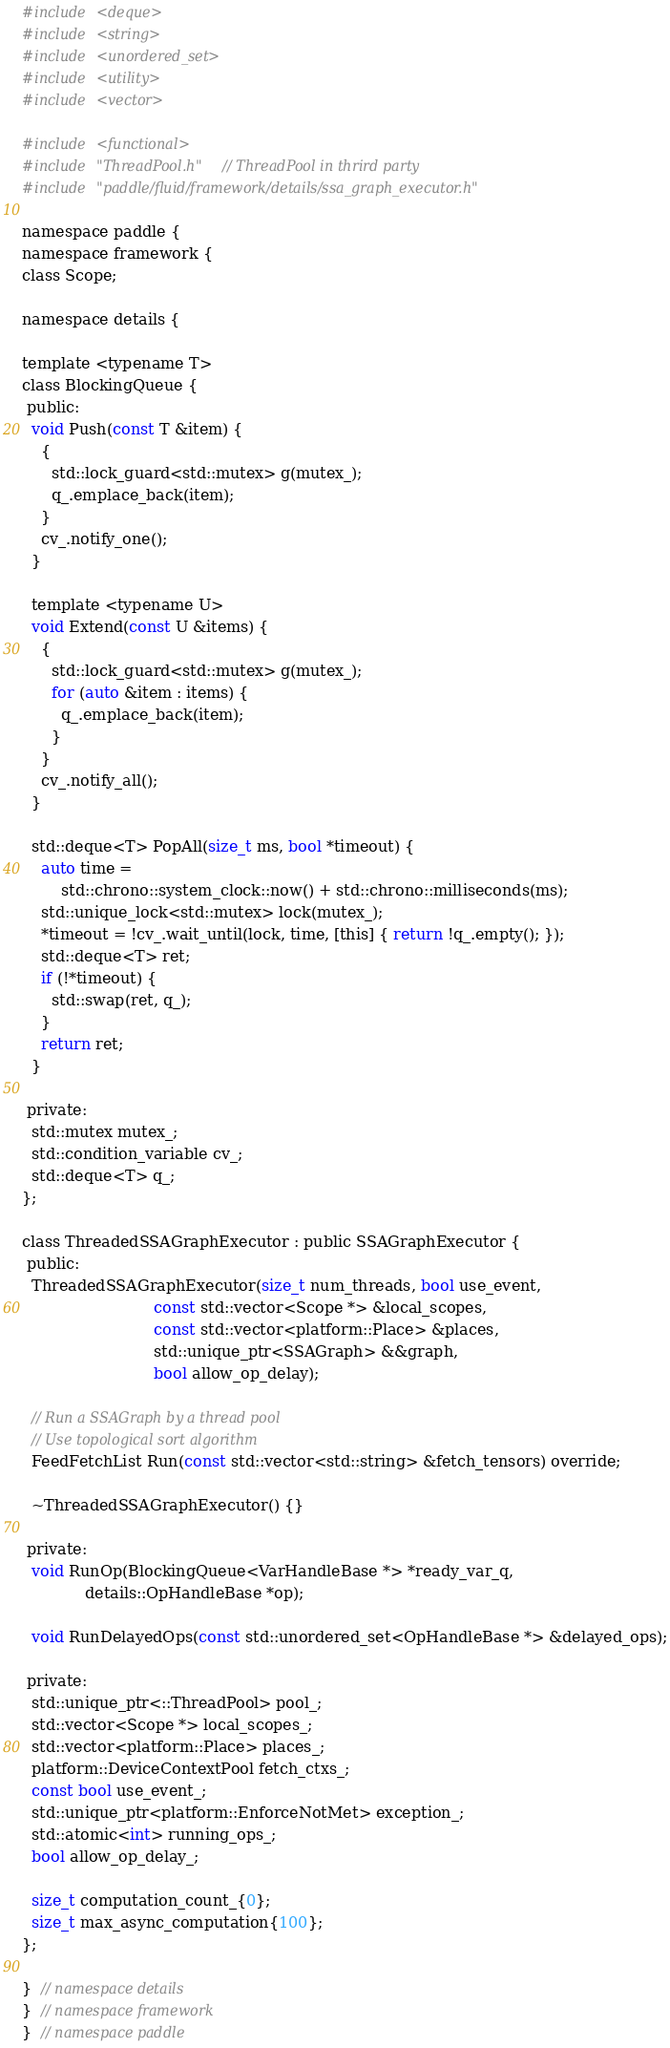Convert code to text. <code><loc_0><loc_0><loc_500><loc_500><_C_>#include <deque>
#include <string>
#include <unordered_set>
#include <utility>
#include <vector>

#include <functional>
#include "ThreadPool.h"  // ThreadPool in thrird party
#include "paddle/fluid/framework/details/ssa_graph_executor.h"

namespace paddle {
namespace framework {
class Scope;

namespace details {

template <typename T>
class BlockingQueue {
 public:
  void Push(const T &item) {
    {
      std::lock_guard<std::mutex> g(mutex_);
      q_.emplace_back(item);
    }
    cv_.notify_one();
  }

  template <typename U>
  void Extend(const U &items) {
    {
      std::lock_guard<std::mutex> g(mutex_);
      for (auto &item : items) {
        q_.emplace_back(item);
      }
    }
    cv_.notify_all();
  }

  std::deque<T> PopAll(size_t ms, bool *timeout) {
    auto time =
        std::chrono::system_clock::now() + std::chrono::milliseconds(ms);
    std::unique_lock<std::mutex> lock(mutex_);
    *timeout = !cv_.wait_until(lock, time, [this] { return !q_.empty(); });
    std::deque<T> ret;
    if (!*timeout) {
      std::swap(ret, q_);
    }
    return ret;
  }

 private:
  std::mutex mutex_;
  std::condition_variable cv_;
  std::deque<T> q_;
};

class ThreadedSSAGraphExecutor : public SSAGraphExecutor {
 public:
  ThreadedSSAGraphExecutor(size_t num_threads, bool use_event,
                           const std::vector<Scope *> &local_scopes,
                           const std::vector<platform::Place> &places,
                           std::unique_ptr<SSAGraph> &&graph,
                           bool allow_op_delay);

  // Run a SSAGraph by a thread pool
  // Use topological sort algorithm
  FeedFetchList Run(const std::vector<std::string> &fetch_tensors) override;

  ~ThreadedSSAGraphExecutor() {}

 private:
  void RunOp(BlockingQueue<VarHandleBase *> *ready_var_q,
             details::OpHandleBase *op);

  void RunDelayedOps(const std::unordered_set<OpHandleBase *> &delayed_ops);

 private:
  std::unique_ptr<::ThreadPool> pool_;
  std::vector<Scope *> local_scopes_;
  std::vector<platform::Place> places_;
  platform::DeviceContextPool fetch_ctxs_;
  const bool use_event_;
  std::unique_ptr<platform::EnforceNotMet> exception_;
  std::atomic<int> running_ops_;
  bool allow_op_delay_;

  size_t computation_count_{0};
  size_t max_async_computation{100};
};

}  // namespace details
}  // namespace framework
}  // namespace paddle
</code> 